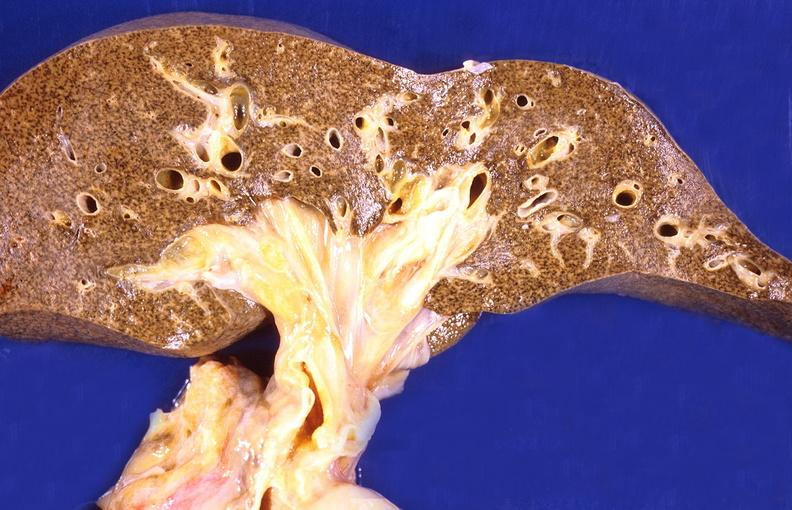s liver present?
Answer the question using a single word or phrase. Yes 